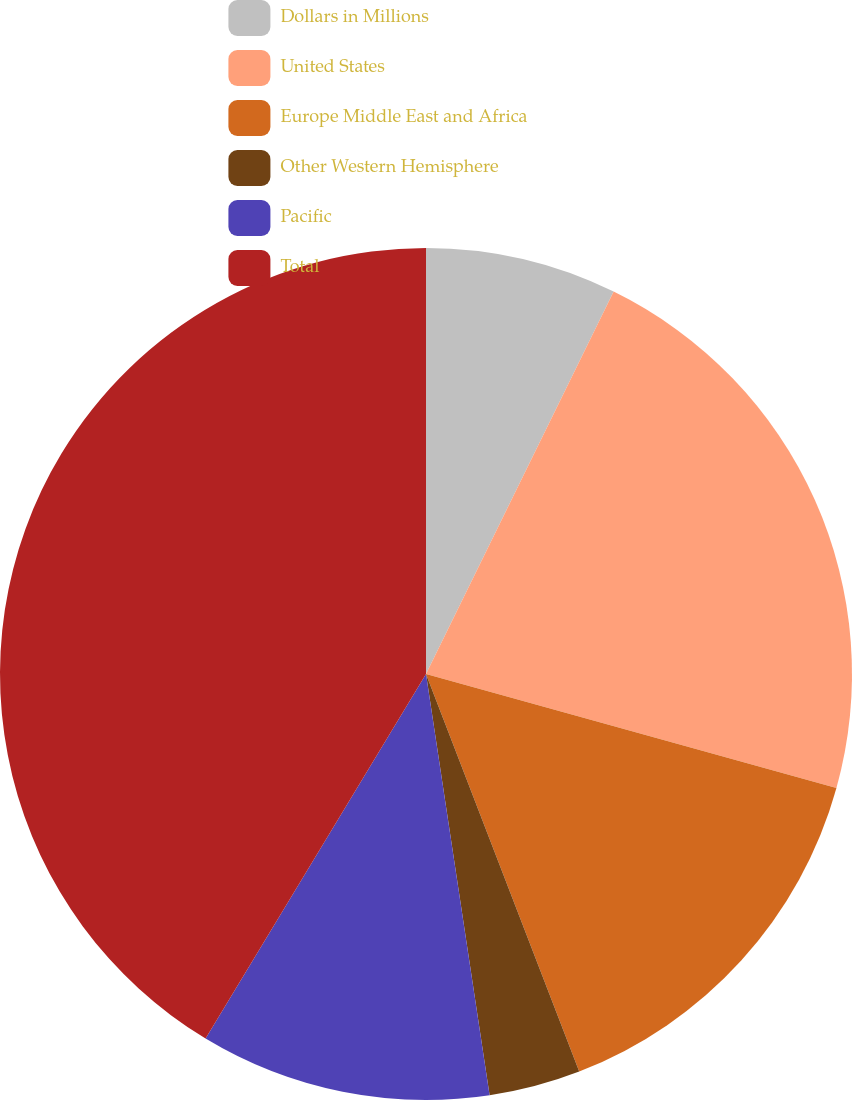<chart> <loc_0><loc_0><loc_500><loc_500><pie_chart><fcel>Dollars in Millions<fcel>United States<fcel>Europe Middle East and Africa<fcel>Other Western Hemisphere<fcel>Pacific<fcel>Total<nl><fcel>7.26%<fcel>22.05%<fcel>14.83%<fcel>3.47%<fcel>11.04%<fcel>41.34%<nl></chart> 